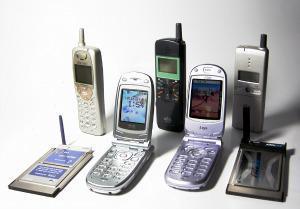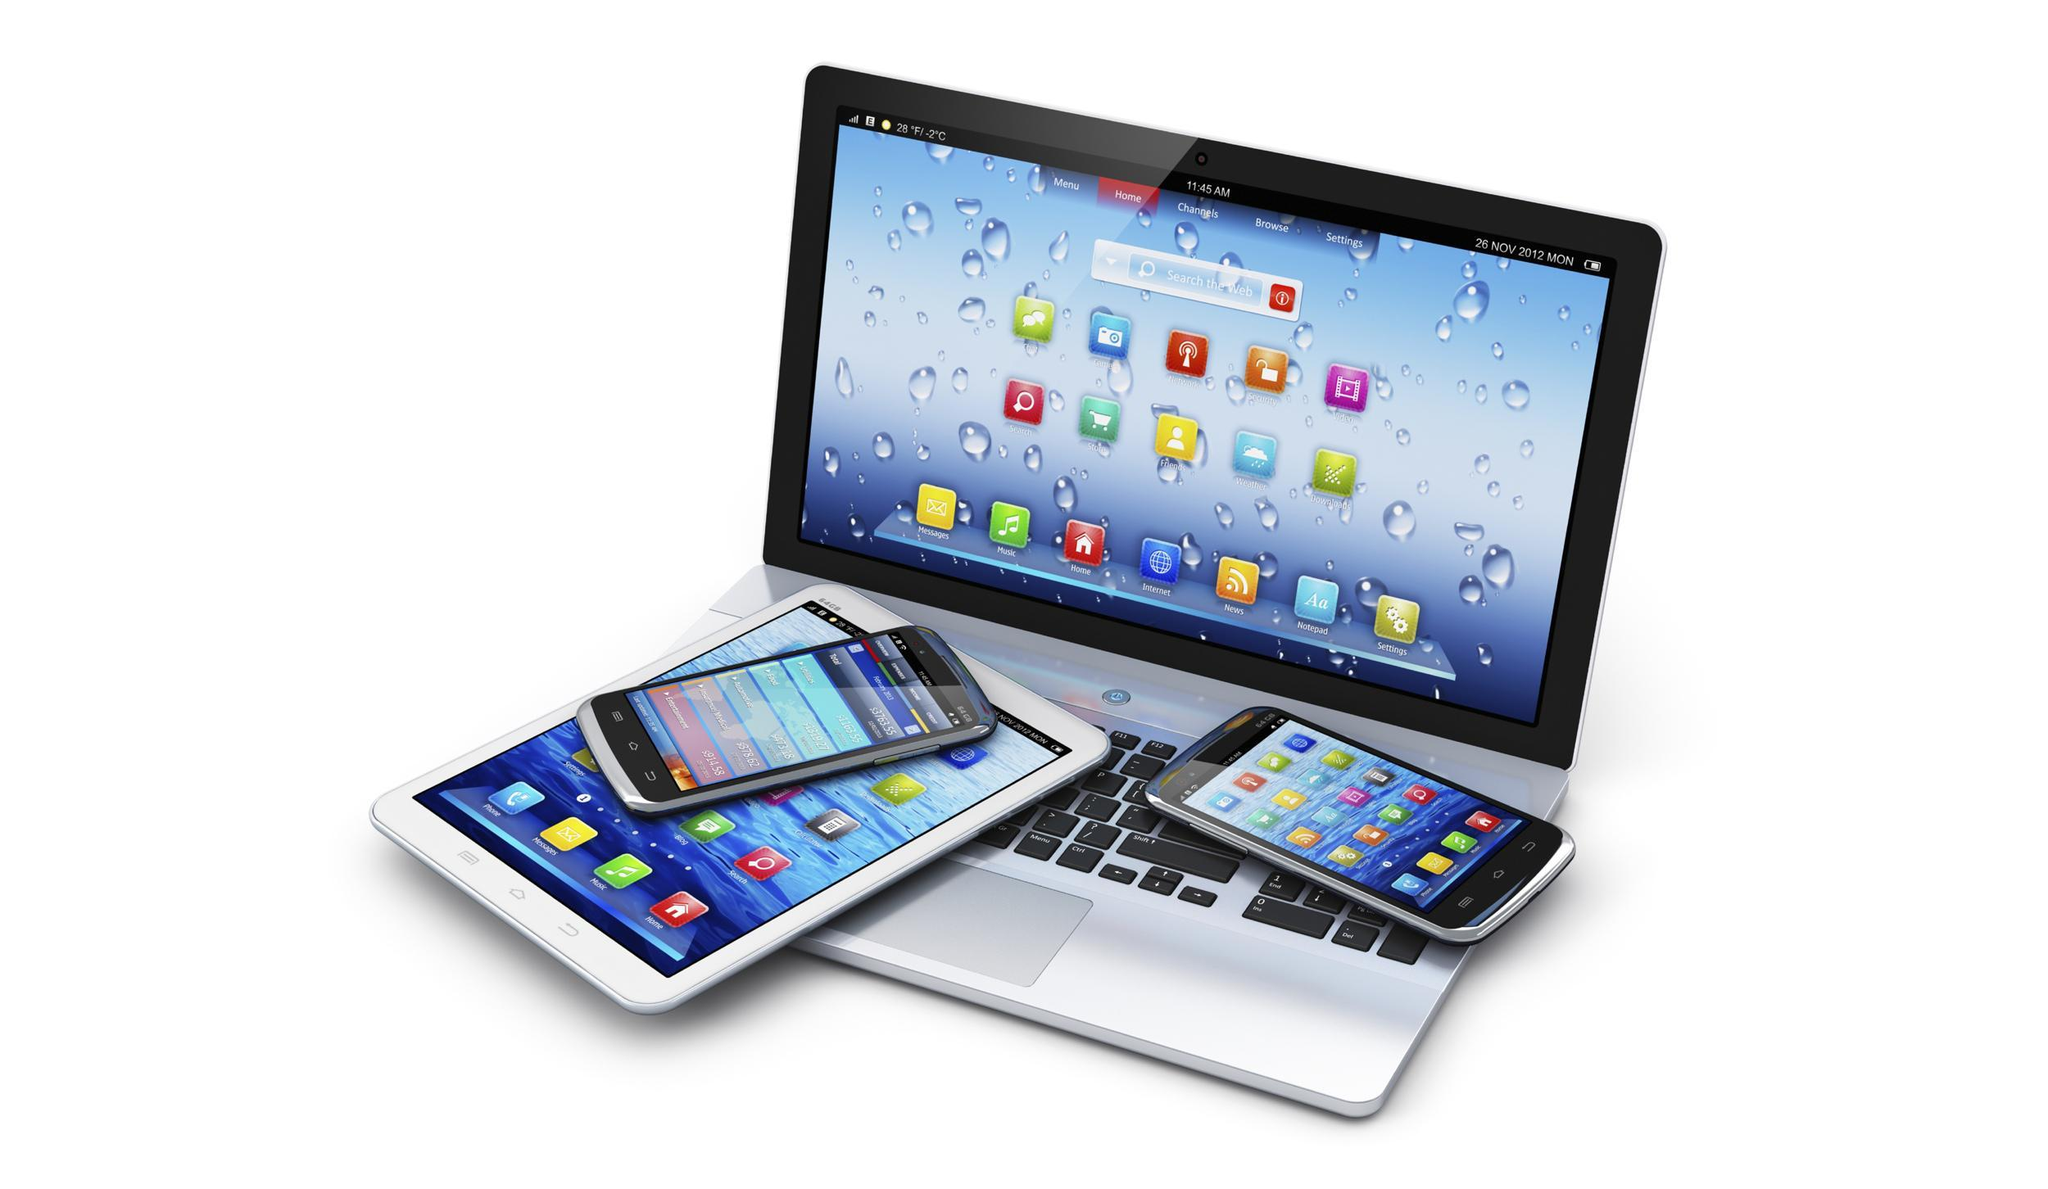The first image is the image on the left, the second image is the image on the right. For the images displayed, is the sentence "There are exactly two phones in the right image." factually correct? Answer yes or no. Yes. 